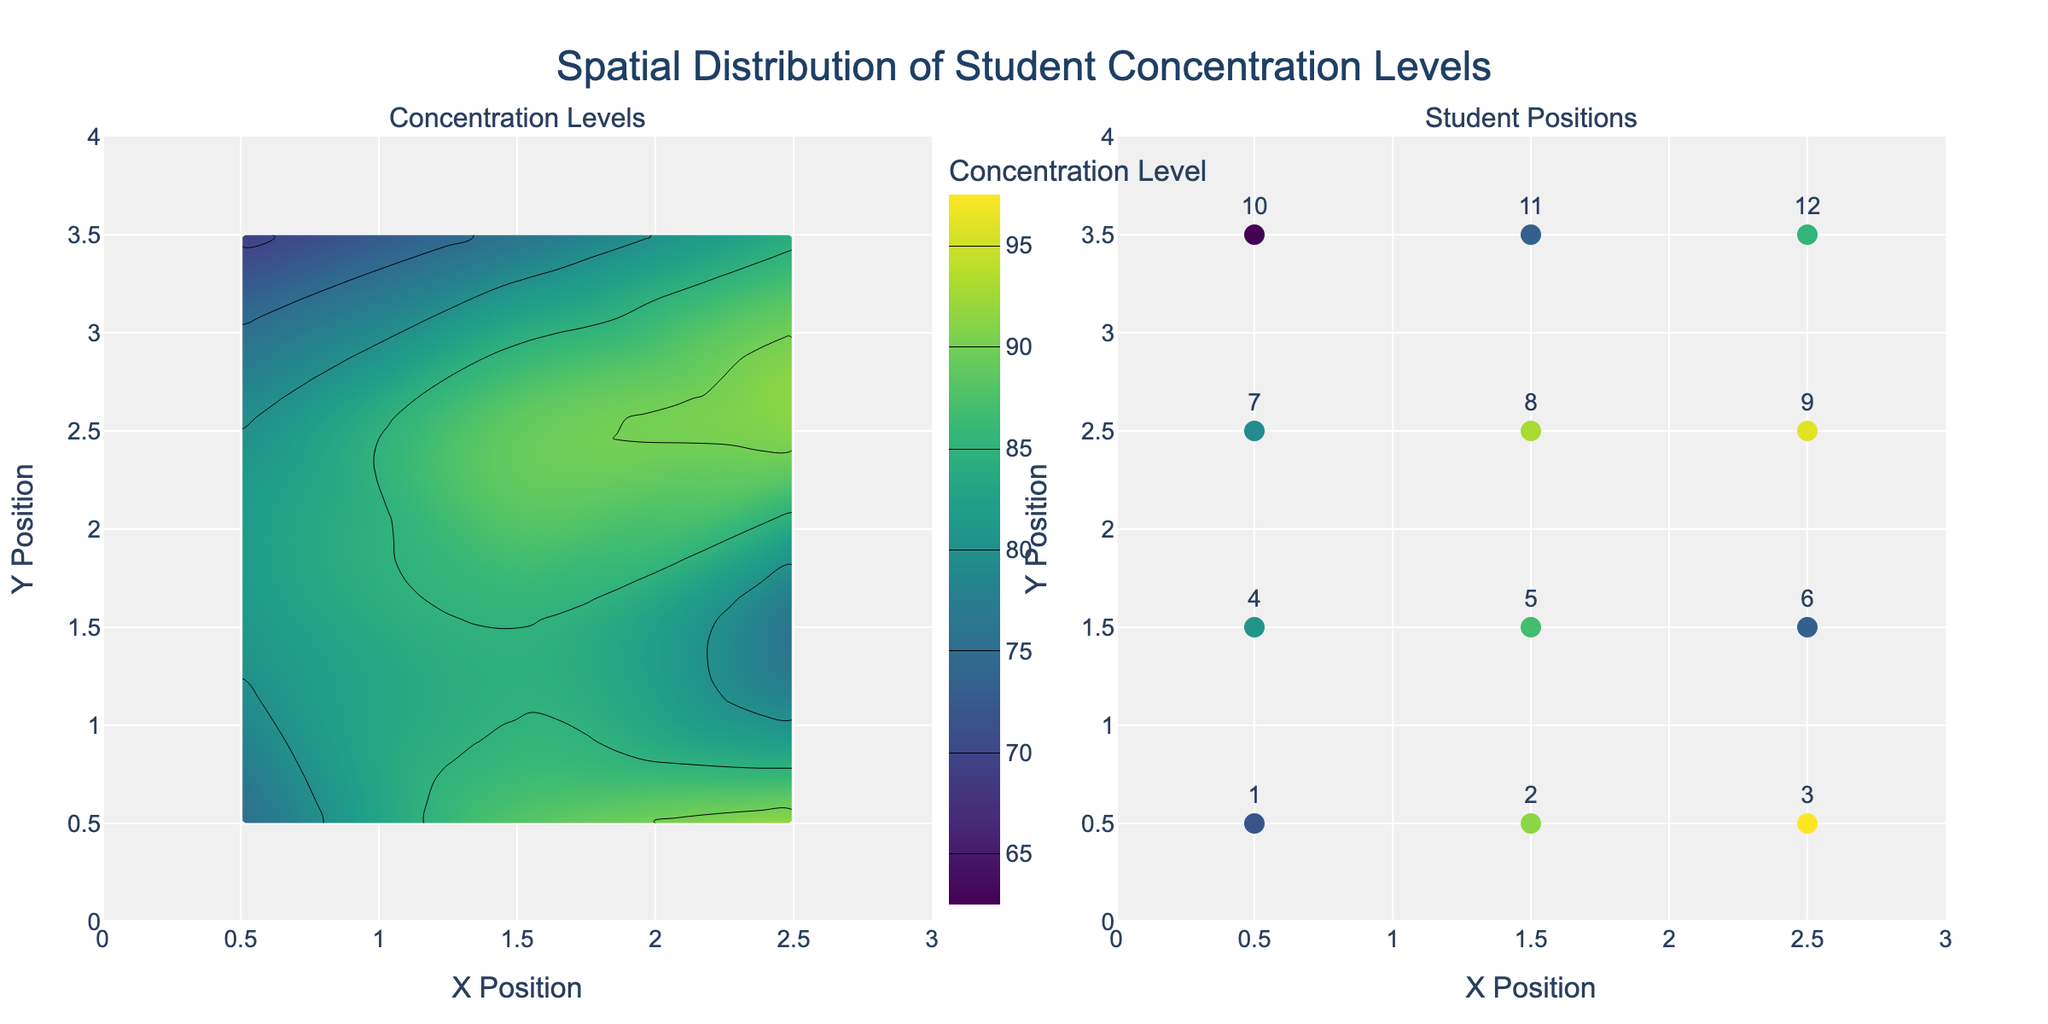What's the overall title of the figure? The title is usually displayed prominently at the top of the figure. In this case, it reads "Spatial Distribution of Student Concentration Levels".
Answer: Spatial Distribution of Student Concentration Levels What do the colors in the contour plot represent? The colors in the contour plot represent different levels of student concentration, with a color gradient from lower to higher values indicated by the colorbar next to the plot.
Answer: Student concentration levels How many student positions are marked on the scatter plot? The scatter plot marks each student position with a different point. Looking at the scatter plot, you can count a total of 12 points.
Answer: 12 Which subplot shows individual student positions? The subplot that shows individual student positions is the one with scatter points marked with student IDs, located on the right side of the figure.
Answer: The right subplot How is the concentration level of each student indicated in the scatter plot? In the scatter plot, each student's concentration level is represented by the color of the marker, with a color gradient corresponding to their specific concentration level.
Answer: By the color of the marker Which student has the highest concentration level and where are they located? By examining the scatter plot, you can identify the student with the highest concentration level by finding the darkest color marker. This corresponds to student 3 with a concentration level of 92, located at (2.5, 0.5).
Answer: Student 3 at (2.5, 0.5) What is the concentration level range depicted in the colorbar of the contour plot? The colorbar next to the contour plot indicates the range of concentration levels, which starts from 65 and goes up to 95.
Answer: 65 to 95 Which area in the classroom has the lowest concentration levels according to the contour plot? The contour plot shows the lowest concentration levels in the lower left corner of the classroom, with concentration values decreasing towards that area.
Answer: Lower left corner What is the difference in concentration levels between students 5 and 9? From the scatter plot, student 5 has a concentration level of 85 and student 9 has a concentration level of 91. The difference is calculated as 91 - 85.
Answer: 6 Which student has the lowest concentration level and what is their position? By finding the lightest colored marker in the scatter plot, you'll see that student 10 has the lowest concentration level of 69, located at (0.5, 3.5).
Answer: Student 10 at (0.5, 3.5) 